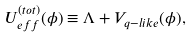<formula> <loc_0><loc_0><loc_500><loc_500>U _ { e f f } ^ { ( t o t ) } ( \phi ) \equiv \Lambda + V _ { q - l i k e } ( \phi ) ,</formula> 